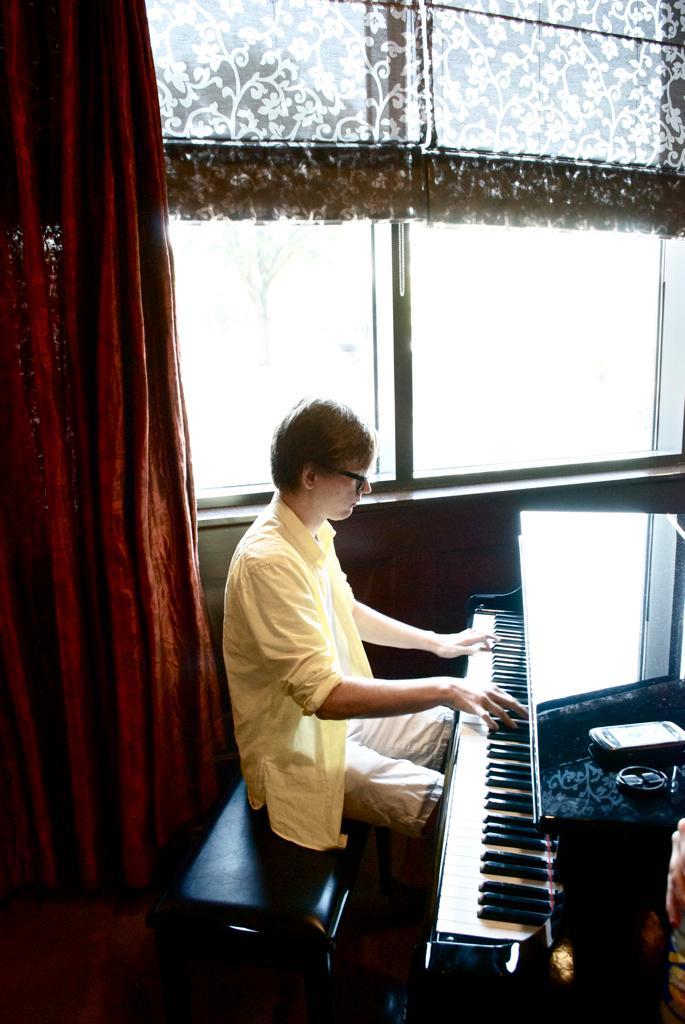How would you summarize this image in a sentence or two? In this image there is a person sitting on a chair and playing a grand piano, there is a mobile and an object, window, curtains. 